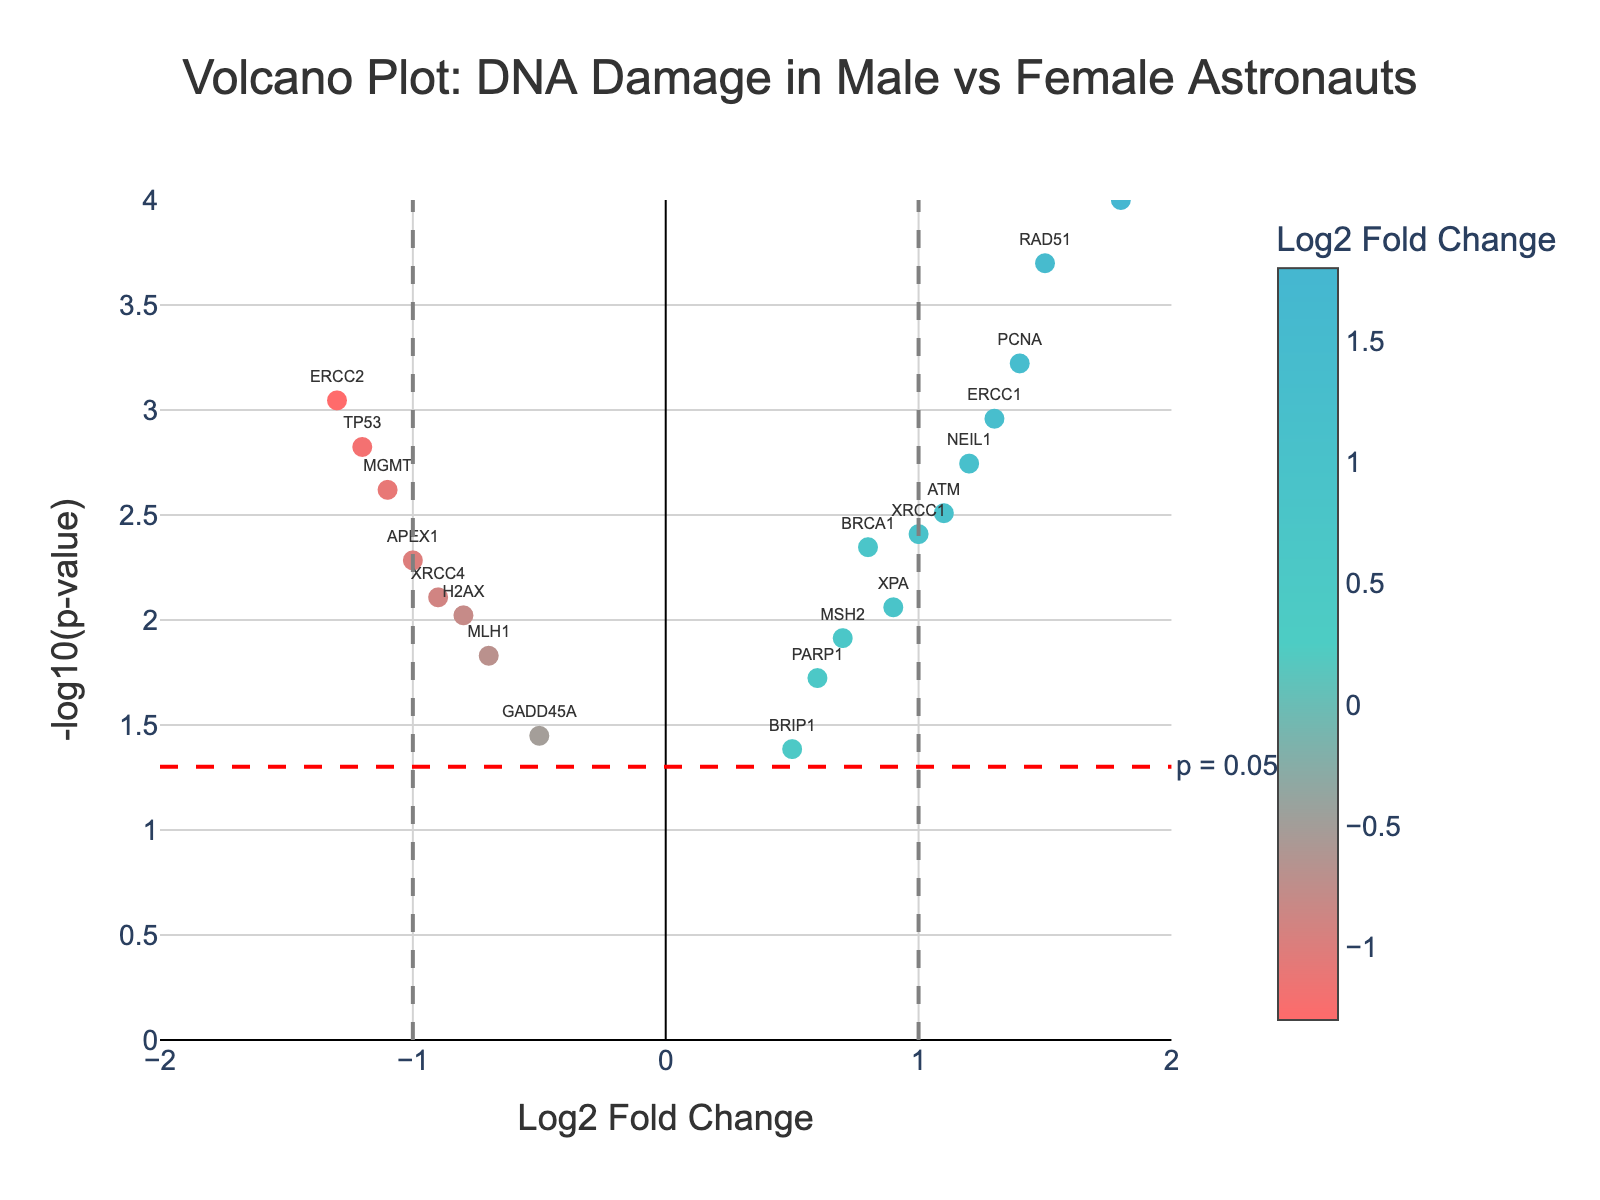How many total genes are plotted in the figure? Count the number of data points (genes) in the scatter plot by identifying each unique text label representing a gene.
Answer: 20 Which gene has the highest Log2 Fold Change value? Examine the plot to identify the data point with the highest Log2 Fold Change value (x-axis) and note the gene label associated with it.
Answer: CDKN1A What is the significance threshold indicated on the plot? Look for the horizontal dashed red line on the plot, which is labeled to indicate the significance threshold.
Answer: p = 0.05 How many genes have a Log2 Fold Change greater than 1 and a p-value less than 0.05? Identify data points to the right of the vertical dashed line at x = 1 and above the horizontal dashed red line. Count the number of such data points.
Answer: 5 Which genes have a Log2 Fold Change less than -1 and a p-value less than 0.05? Identify data points to the left of the vertical dashed line at x = -1 and above the horizontal dashed red line. Note the gene labels for these points.
Answer: ERCC2 and MGMT What is the Log2 Fold Change and p-value for the gene RAD51? Locate the data point labeled RAD51 on the plot. Determine its x-coordinate (Log2 Fold Change) and y-coordinate (-log10(p-value)), then calculate the p-value from the y-coordinate.
Answer: Log2FC: 1.5, p-value: 0.0002 Which genes show a significant decrease in expression (Log2 Fold Change < 0 and p-value < 0.05)? Identify data points to the left of the vertical dashed line at x = 0 and above the horizontal dashed red line. Note the gene labels for these points.
Answer: TP53, XRCC4, ERCC2, APEX1, MGMT What are the Log2 Fold Change values for the genes with the lowest p-values? Identify the data points with the highest y-coordinates (indicating the lowest p-values). Note the Log2 Fold Change values for these points.
Answer: CDKN1A: 1.8, RAD51: 1.5, PCNA: 1.4 Between the genes TP53 and XRCC4, which one shows higher statistical significance? Compare the y-coordinates (-log10(p-value)) of the data points labeled TP53 and XRCC4. The higher y-coordinate indicates greater statistical significance.
Answer: TP53 